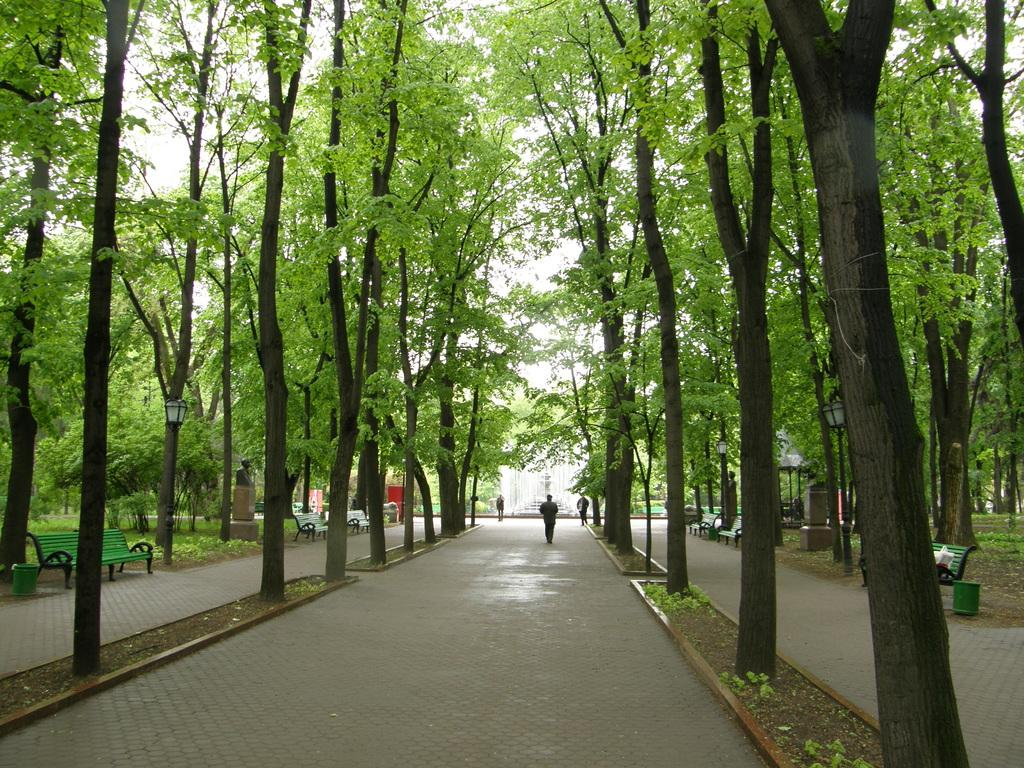What type of seating can be seen in the image? There are benches in the image. What is visible on both sides of the image? Trees are present on both the right and left sides of the image. Where are the people located in the image? There are people in the center of the image. Is the image taken at night? The provided facts do not mention the time of day, so we cannot determine if the image is taken at night. Are there any visitors in the image? The provided facts do not mention any visitors, so we cannot determine if there are any visitors in the image. 